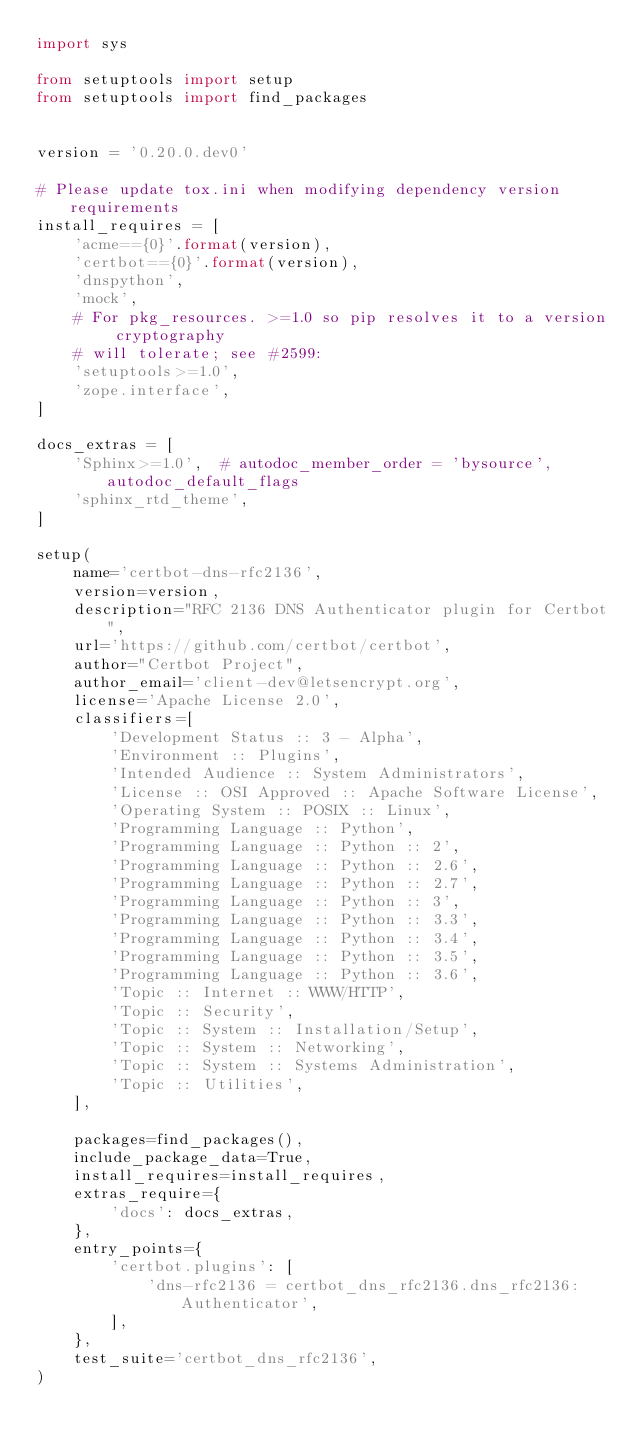Convert code to text. <code><loc_0><loc_0><loc_500><loc_500><_Python_>import sys

from setuptools import setup
from setuptools import find_packages


version = '0.20.0.dev0'

# Please update tox.ini when modifying dependency version requirements
install_requires = [
    'acme=={0}'.format(version),
    'certbot=={0}'.format(version),
    'dnspython',
    'mock',
    # For pkg_resources. >=1.0 so pip resolves it to a version cryptography
    # will tolerate; see #2599:
    'setuptools>=1.0',
    'zope.interface',
]

docs_extras = [
    'Sphinx>=1.0',  # autodoc_member_order = 'bysource', autodoc_default_flags
    'sphinx_rtd_theme',
]

setup(
    name='certbot-dns-rfc2136',
    version=version,
    description="RFC 2136 DNS Authenticator plugin for Certbot",
    url='https://github.com/certbot/certbot',
    author="Certbot Project",
    author_email='client-dev@letsencrypt.org',
    license='Apache License 2.0',
    classifiers=[
        'Development Status :: 3 - Alpha',
        'Environment :: Plugins',
        'Intended Audience :: System Administrators',
        'License :: OSI Approved :: Apache Software License',
        'Operating System :: POSIX :: Linux',
        'Programming Language :: Python',
        'Programming Language :: Python :: 2',
        'Programming Language :: Python :: 2.6',
        'Programming Language :: Python :: 2.7',
        'Programming Language :: Python :: 3',
        'Programming Language :: Python :: 3.3',
        'Programming Language :: Python :: 3.4',
        'Programming Language :: Python :: 3.5',
        'Programming Language :: Python :: 3.6',
        'Topic :: Internet :: WWW/HTTP',
        'Topic :: Security',
        'Topic :: System :: Installation/Setup',
        'Topic :: System :: Networking',
        'Topic :: System :: Systems Administration',
        'Topic :: Utilities',
    ],

    packages=find_packages(),
    include_package_data=True,
    install_requires=install_requires,
    extras_require={
        'docs': docs_extras,
    },
    entry_points={
        'certbot.plugins': [
            'dns-rfc2136 = certbot_dns_rfc2136.dns_rfc2136:Authenticator',
        ],
    },
    test_suite='certbot_dns_rfc2136',
)
</code> 